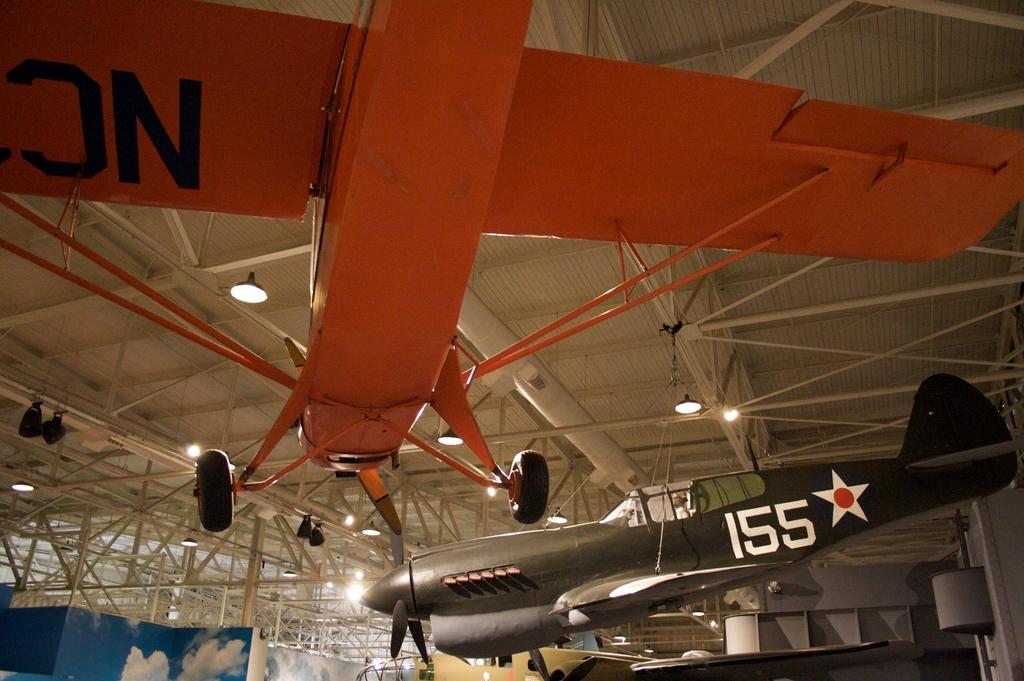Provide a one-sentence caption for the provided image. Planes lettered with 155 and NC hang from the ceiling of a large open building. 